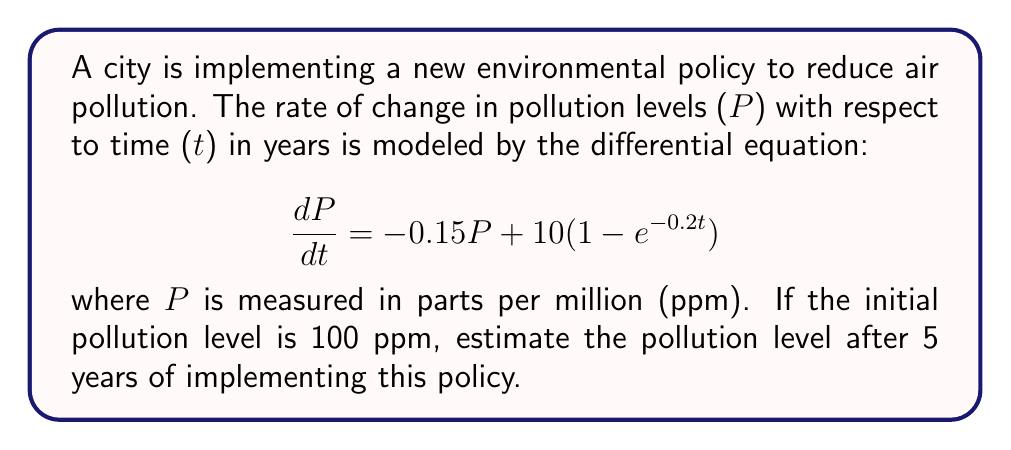Teach me how to tackle this problem. To solve this first-order linear differential equation, we'll use the integrating factor method:

1) First, identify the equation in the standard form:
   $$\frac{dP}{dt} + 0.15P = 10(1 - e^{-0.2t})$$

2) The integrating factor is $\mu(t) = e^{\int 0.15 dt} = e^{0.15t}$

3) Multiply both sides of the equation by the integrating factor:
   $$e^{0.15t}\frac{dP}{dt} + 0.15e^{0.15t}P = 10e^{0.15t}(1 - e^{-0.2t})$$

4) The left side is now the derivative of $e^{0.15t}P$, so we can write:
   $$\frac{d}{dt}(e^{0.15t}P) = 10e^{0.15t} - 10e^{-0.05t}$$

5) Integrate both sides:
   $$e^{0.15t}P = \int (10e^{0.15t} - 10e^{-0.05t}) dt$$
   $$e^{0.15t}P = \frac{10}{0.15}e^{0.15t} + \frac{10}{0.05}e^{-0.05t} + C$$

6) Solve for P:
   $$P = \frac{10}{0.15} + \frac{10}{0.05}e^{-0.2t} + Ce^{-0.15t}$$

7) Use the initial condition P(0) = 100 to find C:
   $$100 = \frac{10}{0.15} + \frac{10}{0.05} + C$$
   $$C = 100 - \frac{10}{0.15} - \frac{10}{0.05} \approx -66.67$$

8) The final solution is:
   $$P(t) = \frac{10}{0.15} + \frac{10}{0.05}e^{-0.2t} - 66.67e^{-0.15t}$$

9) To find P(5), substitute t = 5:
   $$P(5) = \frac{10}{0.15} + \frac{10}{0.05}e^{-0.2(5)} - 66.67e^{-0.15(5)}$$
   $$P(5) \approx 66.67 + 122.14 - 33.85 = 154.96$$
Answer: The estimated pollution level after 5 years of implementing the policy is approximately 154.96 ppm. 